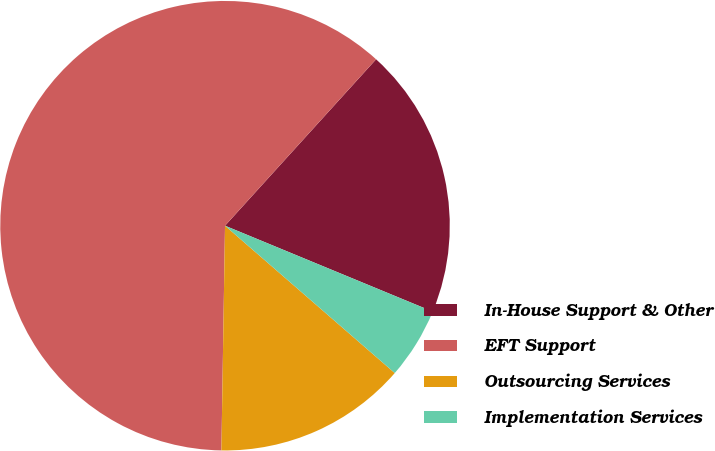Convert chart to OTSL. <chart><loc_0><loc_0><loc_500><loc_500><pie_chart><fcel>In-House Support & Other<fcel>EFT Support<fcel>Outsourcing Services<fcel>Implementation Services<nl><fcel>19.51%<fcel>61.48%<fcel>13.88%<fcel>5.14%<nl></chart> 